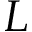<formula> <loc_0><loc_0><loc_500><loc_500>L</formula> 